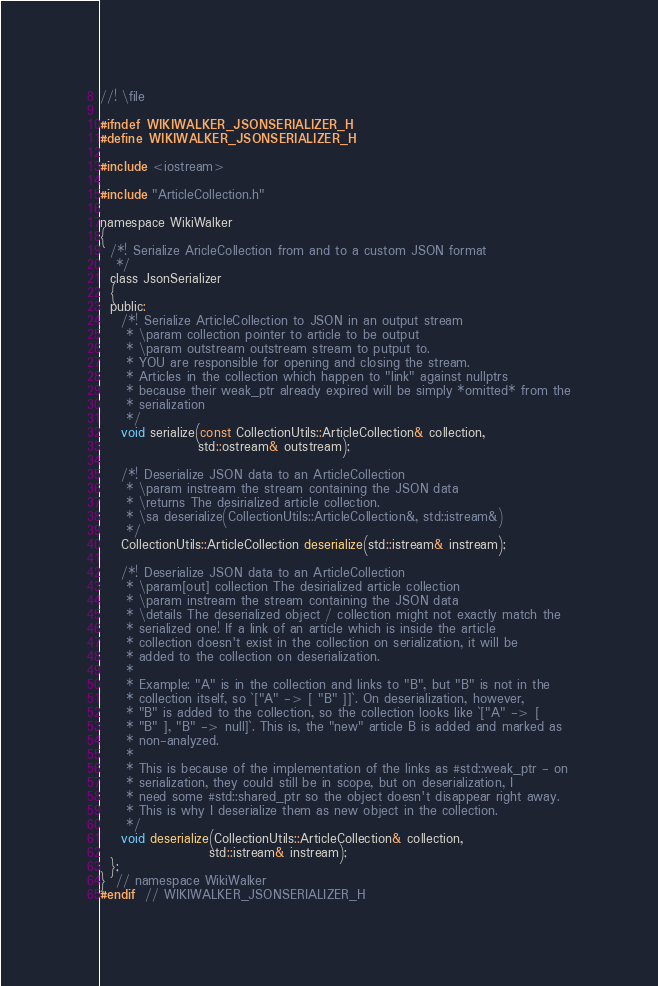<code> <loc_0><loc_0><loc_500><loc_500><_C_>//! \file

#ifndef WIKIWALKER_JSONSERIALIZER_H
#define WIKIWALKER_JSONSERIALIZER_H

#include <iostream>

#include "ArticleCollection.h"

namespace WikiWalker
{
  /*! Serialize AricleCollection from and to a custom JSON format
   */
  class JsonSerializer
  {
  public:
    /*! Serialize ArticleCollection to JSON in an output stream
     * \param collection pointer to article to be output
     * \param outstream outstream stream to putput to.
     * YOU are responsible for opening and closing the stream.
     * Articles in the collection which happen to "link" against nullptrs
     * because their weak_ptr already expired will be simply *omitted* from the
     * serialization
     */
    void serialize(const CollectionUtils::ArticleCollection& collection,
                   std::ostream& outstream);

    /*! Deserialize JSON data to an ArticleCollection
     * \param instream the stream containing the JSON data
     * \returns The desirialized article collection.
     * \sa deserialize(CollectionUtils::ArticleCollection&, std::istream&)
     */
    CollectionUtils::ArticleCollection deserialize(std::istream& instream);

    /*! Deserialize JSON data to an ArticleCollection
     * \param[out] collection The desirialized article collection
     * \param instream the stream containing the JSON data
     * \details The deserialized object / collection might not exactly match the
     * serialized one! If a link of an article which is inside the article
     * collection doesn't exist in the collection on serialization, it will be
     * added to the collection on deserialization.
     *
     * Example: "A" is in the collection and links to "B", but "B" is not in the
     * collection itself, so `["A" -> [ "B" ]]`. On deserialization, however,
     * "B" is added to the collection, so the collection looks like `["A" -> [
     * "B" ], "B" -> null]`. This is, the "new" article B is added and marked as
     * non-analyzed.
     *
     * This is because of the implementation of the links as #std::weak_ptr - on
     * serialization, they could still be in scope, but on deserialization, I
     * need some #std::shared_ptr so the object doesn't disappear right away.
     * This is why I deserialize them as new object in the collection.
     */
    void deserialize(CollectionUtils::ArticleCollection& collection,
                     std::istream& instream);
  };
}  // namespace WikiWalker
#endif  // WIKIWALKER_JSONSERIALIZER_H
</code> 